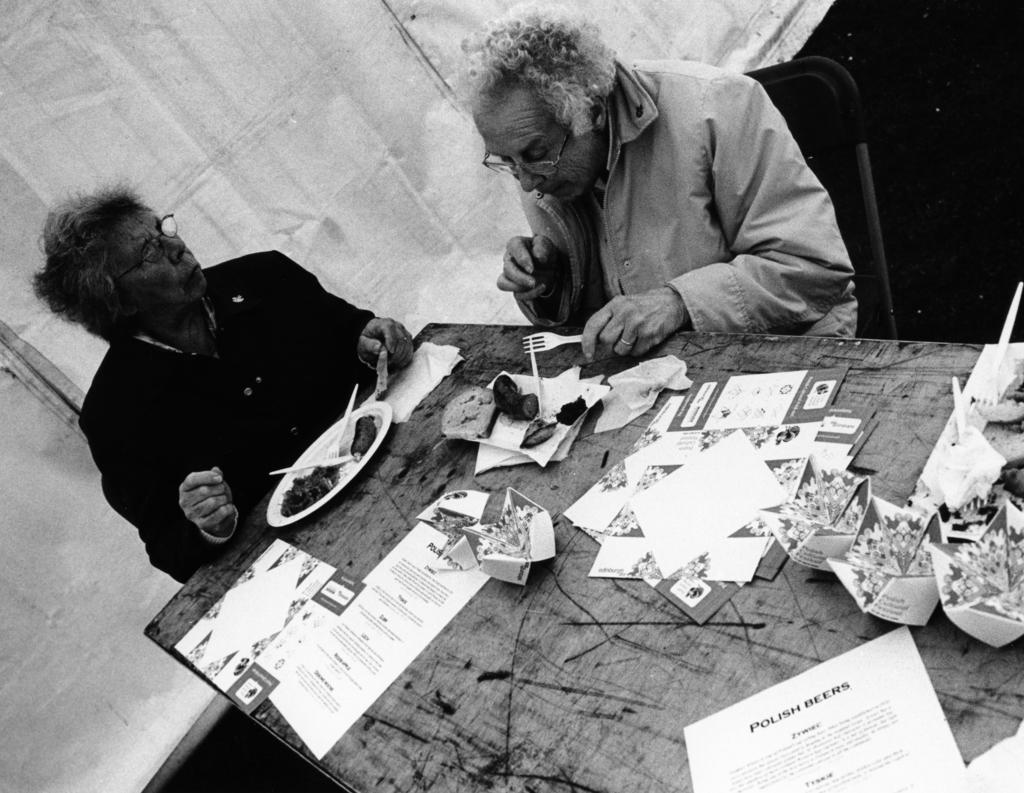How many people are sitting in the image? There are two people sitting on chairs in the image. What is on the plate that is visible in the image? There is food in a plate in the image. What utensils are visible in the image? There are forks and spoons visible in the image. What objects are used for serving food in the image? There are plates visible in the image. What else can be seen on the table in the image? There are papers and cards visible on the table in the image. What type of yarn is being used to create the patterns on the cards in the image? There is no yarn present in the image, and the cards do not have any patterns created by yarn. 